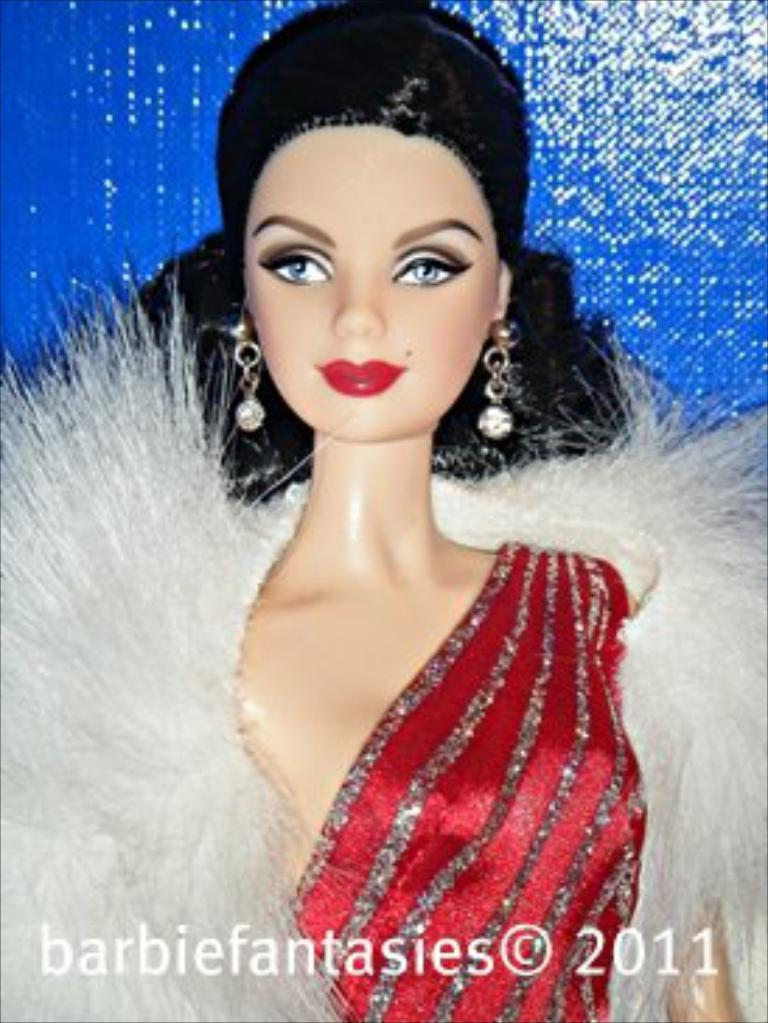What object can be seen in the image? There is a toy in the image. What is unique about the toy's appearance? The toy is wearing earrings. What color is the wall in the background of the image? There is a blue wall in the background of the image. What is present at the bottom of the image? There is a watermark at the bottom of the image. How many tomatoes are hanging on the calendar in the image? There is no calendar or tomatoes present in the image. What activity is the toy participating in within the image? The image does not depict the toy participating in any activity; it simply shows the toy wearing earrings. 